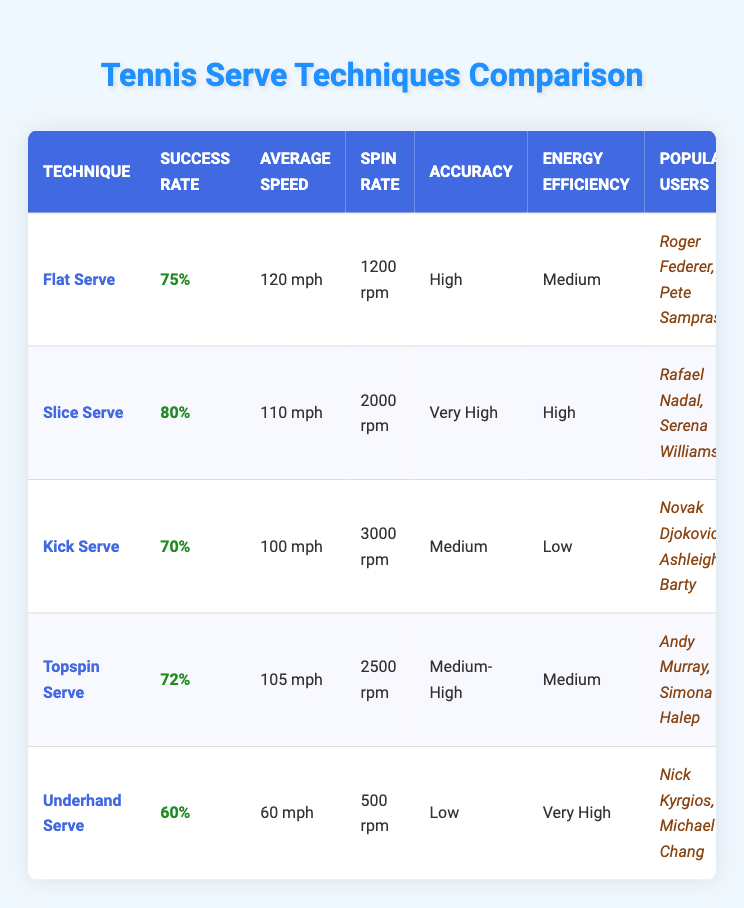What is the success rate of the Slice Serve? The Slice Serve's success rate is specifically listed in the table under the "Success Rate" column. It states "80%" for this technique.
Answer: 80% Which serve technique has the highest average speed? The table shows the average speed for each serve technique. The Flat Serve has the highest average speed listed as "120 mph".
Answer: Flat Serve How much faster is the Flat Serve compared to the Underhand Serve? The average speed of the Flat Serve is "120 mph" and the Underhand Serve is "60 mph". To find the difference, subtract 60 from 120, which equals 60 mph.
Answer: 60 mph Is the Kick Serve's accuracy rated as High? From the table, the Kick Serve's accuracy is listed as "Medium," so it is not rated as High.
Answer: No Which serve technique has the lowest success rate and low energy efficiency? According to the table, the Underhand Serve has the lowest success rate at "60%" and is also noted for having "Very High" energy efficiency. However, the Kick Serve has both low success rate "70%" and is rated as "Low" on energy efficiency. Therefore, no serve fits both criteria.
Answer: No serve fits both criteria What is the average success rate of the Topspin Serve and the Kick Serve together? The success rate for the Topspin Serve is "72%" and for the Kick Serve is "70%". To calculate the average, add the two percentages together (72 + 70 = 142) and divide by 2, which equals 71%.
Answer: 71% 